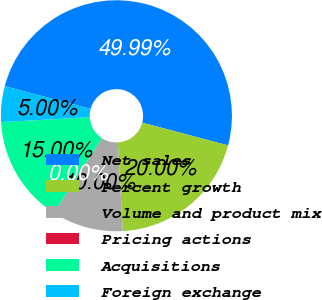Convert chart. <chart><loc_0><loc_0><loc_500><loc_500><pie_chart><fcel>Net sales<fcel>Percent growth<fcel>Volume and product mix<fcel>Pricing actions<fcel>Acquisitions<fcel>Foreign exchange<nl><fcel>49.99%<fcel>20.0%<fcel>10.0%<fcel>0.0%<fcel>15.0%<fcel>5.0%<nl></chart> 